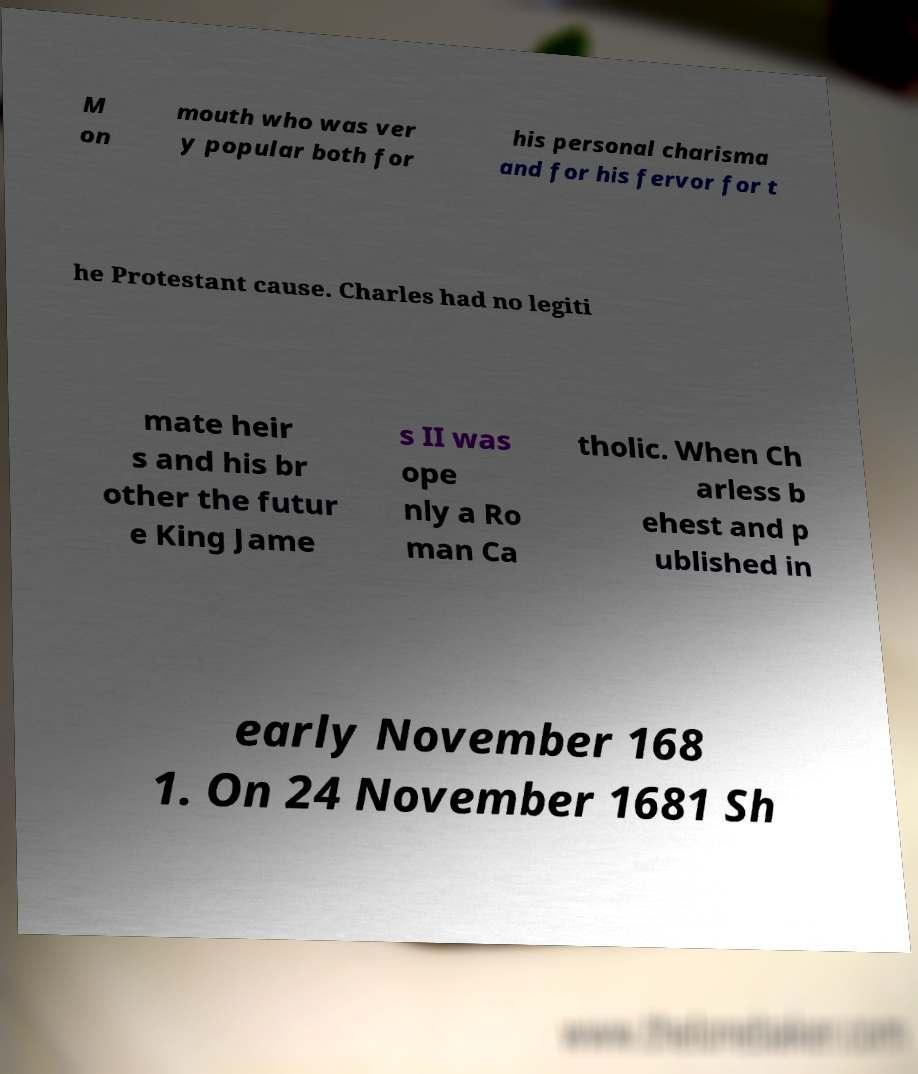Could you extract and type out the text from this image? M on mouth who was ver y popular both for his personal charisma and for his fervor for t he Protestant cause. Charles had no legiti mate heir s and his br other the futur e King Jame s II was ope nly a Ro man Ca tholic. When Ch arless b ehest and p ublished in early November 168 1. On 24 November 1681 Sh 